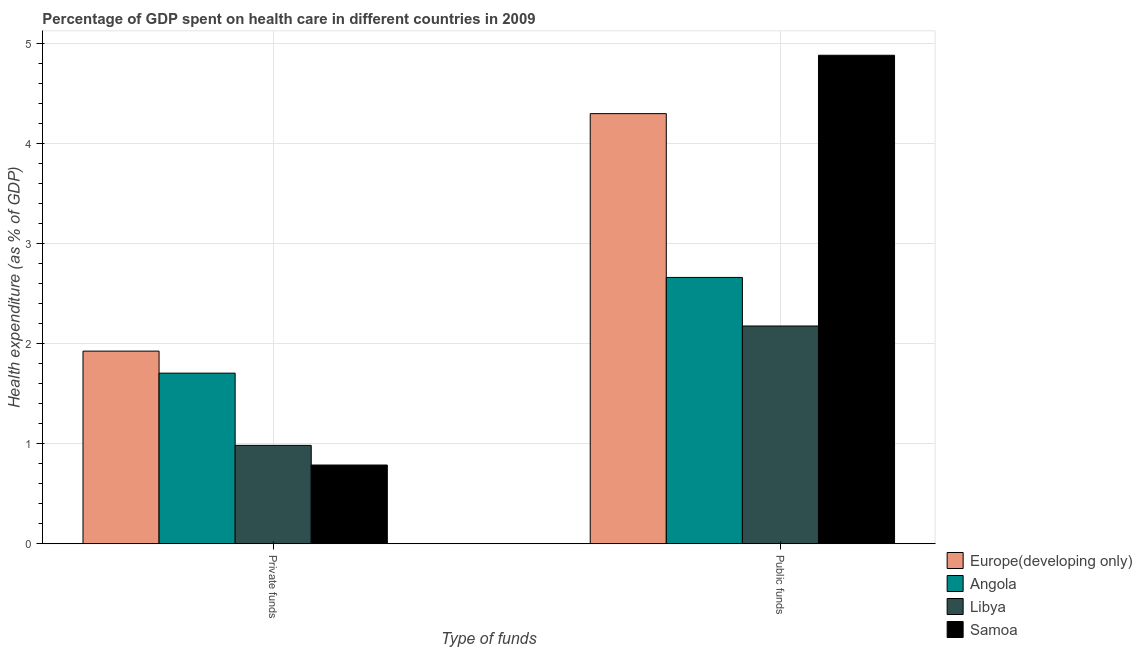Are the number of bars on each tick of the X-axis equal?
Ensure brevity in your answer.  Yes. What is the label of the 1st group of bars from the left?
Your answer should be very brief. Private funds. What is the amount of private funds spent in healthcare in Europe(developing only)?
Give a very brief answer. 1.93. Across all countries, what is the maximum amount of public funds spent in healthcare?
Ensure brevity in your answer.  4.89. Across all countries, what is the minimum amount of public funds spent in healthcare?
Keep it short and to the point. 2.18. In which country was the amount of private funds spent in healthcare maximum?
Provide a succinct answer. Europe(developing only). In which country was the amount of public funds spent in healthcare minimum?
Make the answer very short. Libya. What is the total amount of private funds spent in healthcare in the graph?
Provide a short and direct response. 5.41. What is the difference between the amount of private funds spent in healthcare in Europe(developing only) and that in Angola?
Ensure brevity in your answer.  0.22. What is the difference between the amount of public funds spent in healthcare in Libya and the amount of private funds spent in healthcare in Europe(developing only)?
Provide a short and direct response. 0.25. What is the average amount of public funds spent in healthcare per country?
Your answer should be compact. 3.51. What is the difference between the amount of public funds spent in healthcare and amount of private funds spent in healthcare in Samoa?
Offer a terse response. 4.1. What is the ratio of the amount of private funds spent in healthcare in Samoa to that in Europe(developing only)?
Your answer should be very brief. 0.41. Is the amount of public funds spent in healthcare in Angola less than that in Libya?
Make the answer very short. No. What does the 1st bar from the left in Public funds represents?
Ensure brevity in your answer.  Europe(developing only). What does the 2nd bar from the right in Public funds represents?
Your answer should be very brief. Libya. How many bars are there?
Your answer should be very brief. 8. How many legend labels are there?
Your answer should be very brief. 4. What is the title of the graph?
Provide a short and direct response. Percentage of GDP spent on health care in different countries in 2009. Does "Sint Maarten (Dutch part)" appear as one of the legend labels in the graph?
Your answer should be compact. No. What is the label or title of the X-axis?
Your answer should be very brief. Type of funds. What is the label or title of the Y-axis?
Keep it short and to the point. Health expenditure (as % of GDP). What is the Health expenditure (as % of GDP) in Europe(developing only) in Private funds?
Ensure brevity in your answer.  1.93. What is the Health expenditure (as % of GDP) in Angola in Private funds?
Give a very brief answer. 1.71. What is the Health expenditure (as % of GDP) in Libya in Private funds?
Your answer should be compact. 0.98. What is the Health expenditure (as % of GDP) of Samoa in Private funds?
Provide a short and direct response. 0.79. What is the Health expenditure (as % of GDP) in Europe(developing only) in Public funds?
Make the answer very short. 4.3. What is the Health expenditure (as % of GDP) of Angola in Public funds?
Offer a very short reply. 2.66. What is the Health expenditure (as % of GDP) of Libya in Public funds?
Your response must be concise. 2.18. What is the Health expenditure (as % of GDP) in Samoa in Public funds?
Give a very brief answer. 4.89. Across all Type of funds, what is the maximum Health expenditure (as % of GDP) of Europe(developing only)?
Your answer should be compact. 4.3. Across all Type of funds, what is the maximum Health expenditure (as % of GDP) of Angola?
Keep it short and to the point. 2.66. Across all Type of funds, what is the maximum Health expenditure (as % of GDP) in Libya?
Keep it short and to the point. 2.18. Across all Type of funds, what is the maximum Health expenditure (as % of GDP) of Samoa?
Your answer should be compact. 4.89. Across all Type of funds, what is the minimum Health expenditure (as % of GDP) in Europe(developing only)?
Your response must be concise. 1.93. Across all Type of funds, what is the minimum Health expenditure (as % of GDP) in Angola?
Provide a succinct answer. 1.71. Across all Type of funds, what is the minimum Health expenditure (as % of GDP) of Libya?
Provide a short and direct response. 0.98. Across all Type of funds, what is the minimum Health expenditure (as % of GDP) of Samoa?
Offer a very short reply. 0.79. What is the total Health expenditure (as % of GDP) in Europe(developing only) in the graph?
Offer a terse response. 6.23. What is the total Health expenditure (as % of GDP) in Angola in the graph?
Your response must be concise. 4.37. What is the total Health expenditure (as % of GDP) in Libya in the graph?
Keep it short and to the point. 3.16. What is the total Health expenditure (as % of GDP) in Samoa in the graph?
Offer a terse response. 5.67. What is the difference between the Health expenditure (as % of GDP) of Europe(developing only) in Private funds and that in Public funds?
Offer a very short reply. -2.38. What is the difference between the Health expenditure (as % of GDP) of Angola in Private funds and that in Public funds?
Your answer should be compact. -0.96. What is the difference between the Health expenditure (as % of GDP) in Libya in Private funds and that in Public funds?
Keep it short and to the point. -1.19. What is the difference between the Health expenditure (as % of GDP) in Samoa in Private funds and that in Public funds?
Keep it short and to the point. -4.1. What is the difference between the Health expenditure (as % of GDP) in Europe(developing only) in Private funds and the Health expenditure (as % of GDP) in Angola in Public funds?
Ensure brevity in your answer.  -0.74. What is the difference between the Health expenditure (as % of GDP) in Europe(developing only) in Private funds and the Health expenditure (as % of GDP) in Libya in Public funds?
Your answer should be very brief. -0.25. What is the difference between the Health expenditure (as % of GDP) in Europe(developing only) in Private funds and the Health expenditure (as % of GDP) in Samoa in Public funds?
Offer a very short reply. -2.96. What is the difference between the Health expenditure (as % of GDP) in Angola in Private funds and the Health expenditure (as % of GDP) in Libya in Public funds?
Your response must be concise. -0.47. What is the difference between the Health expenditure (as % of GDP) in Angola in Private funds and the Health expenditure (as % of GDP) in Samoa in Public funds?
Your answer should be compact. -3.18. What is the difference between the Health expenditure (as % of GDP) of Libya in Private funds and the Health expenditure (as % of GDP) of Samoa in Public funds?
Offer a terse response. -3.9. What is the average Health expenditure (as % of GDP) in Europe(developing only) per Type of funds?
Ensure brevity in your answer.  3.11. What is the average Health expenditure (as % of GDP) in Angola per Type of funds?
Provide a succinct answer. 2.19. What is the average Health expenditure (as % of GDP) in Libya per Type of funds?
Provide a short and direct response. 1.58. What is the average Health expenditure (as % of GDP) in Samoa per Type of funds?
Give a very brief answer. 2.84. What is the difference between the Health expenditure (as % of GDP) of Europe(developing only) and Health expenditure (as % of GDP) of Angola in Private funds?
Give a very brief answer. 0.22. What is the difference between the Health expenditure (as % of GDP) in Europe(developing only) and Health expenditure (as % of GDP) in Libya in Private funds?
Offer a very short reply. 0.94. What is the difference between the Health expenditure (as % of GDP) of Europe(developing only) and Health expenditure (as % of GDP) of Samoa in Private funds?
Give a very brief answer. 1.14. What is the difference between the Health expenditure (as % of GDP) of Angola and Health expenditure (as % of GDP) of Libya in Private funds?
Make the answer very short. 0.72. What is the difference between the Health expenditure (as % of GDP) in Angola and Health expenditure (as % of GDP) in Samoa in Private funds?
Give a very brief answer. 0.92. What is the difference between the Health expenditure (as % of GDP) in Libya and Health expenditure (as % of GDP) in Samoa in Private funds?
Your answer should be compact. 0.2. What is the difference between the Health expenditure (as % of GDP) of Europe(developing only) and Health expenditure (as % of GDP) of Angola in Public funds?
Your answer should be very brief. 1.64. What is the difference between the Health expenditure (as % of GDP) of Europe(developing only) and Health expenditure (as % of GDP) of Libya in Public funds?
Your answer should be compact. 2.12. What is the difference between the Health expenditure (as % of GDP) in Europe(developing only) and Health expenditure (as % of GDP) in Samoa in Public funds?
Offer a very short reply. -0.58. What is the difference between the Health expenditure (as % of GDP) in Angola and Health expenditure (as % of GDP) in Libya in Public funds?
Provide a succinct answer. 0.49. What is the difference between the Health expenditure (as % of GDP) of Angola and Health expenditure (as % of GDP) of Samoa in Public funds?
Make the answer very short. -2.22. What is the difference between the Health expenditure (as % of GDP) of Libya and Health expenditure (as % of GDP) of Samoa in Public funds?
Keep it short and to the point. -2.71. What is the ratio of the Health expenditure (as % of GDP) of Europe(developing only) in Private funds to that in Public funds?
Offer a terse response. 0.45. What is the ratio of the Health expenditure (as % of GDP) in Angola in Private funds to that in Public funds?
Your response must be concise. 0.64. What is the ratio of the Health expenditure (as % of GDP) in Libya in Private funds to that in Public funds?
Your answer should be very brief. 0.45. What is the ratio of the Health expenditure (as % of GDP) in Samoa in Private funds to that in Public funds?
Ensure brevity in your answer.  0.16. What is the difference between the highest and the second highest Health expenditure (as % of GDP) in Europe(developing only)?
Your answer should be very brief. 2.38. What is the difference between the highest and the second highest Health expenditure (as % of GDP) of Angola?
Your response must be concise. 0.96. What is the difference between the highest and the second highest Health expenditure (as % of GDP) in Libya?
Keep it short and to the point. 1.19. What is the difference between the highest and the second highest Health expenditure (as % of GDP) in Samoa?
Offer a terse response. 4.1. What is the difference between the highest and the lowest Health expenditure (as % of GDP) in Europe(developing only)?
Provide a short and direct response. 2.38. What is the difference between the highest and the lowest Health expenditure (as % of GDP) in Angola?
Provide a short and direct response. 0.96. What is the difference between the highest and the lowest Health expenditure (as % of GDP) of Libya?
Give a very brief answer. 1.19. What is the difference between the highest and the lowest Health expenditure (as % of GDP) in Samoa?
Ensure brevity in your answer.  4.1. 